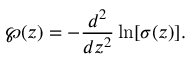Convert formula to latex. <formula><loc_0><loc_0><loc_500><loc_500>\wp ( z ) = - \frac { d ^ { 2 } } { d z ^ { 2 } } \ln [ \sigma ( z ) ] .</formula> 